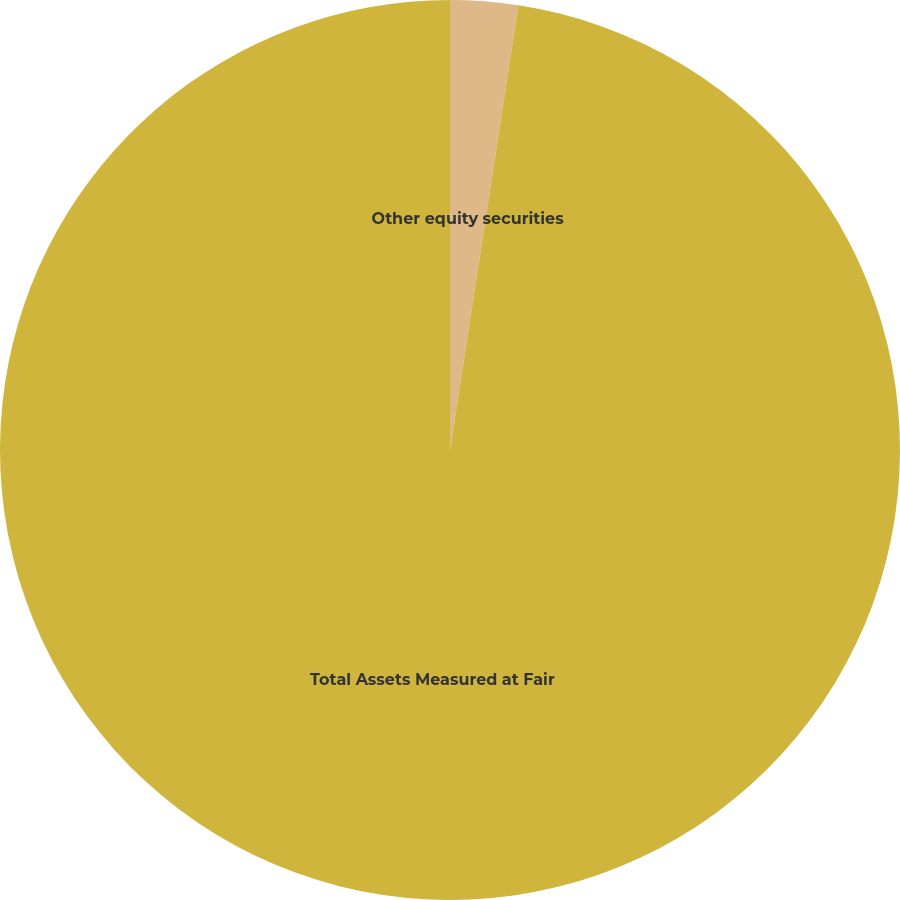Convert chart to OTSL. <chart><loc_0><loc_0><loc_500><loc_500><pie_chart><fcel>Other equity securities<fcel>Total Assets Measured at Fair<nl><fcel>2.43%<fcel>97.57%<nl></chart> 